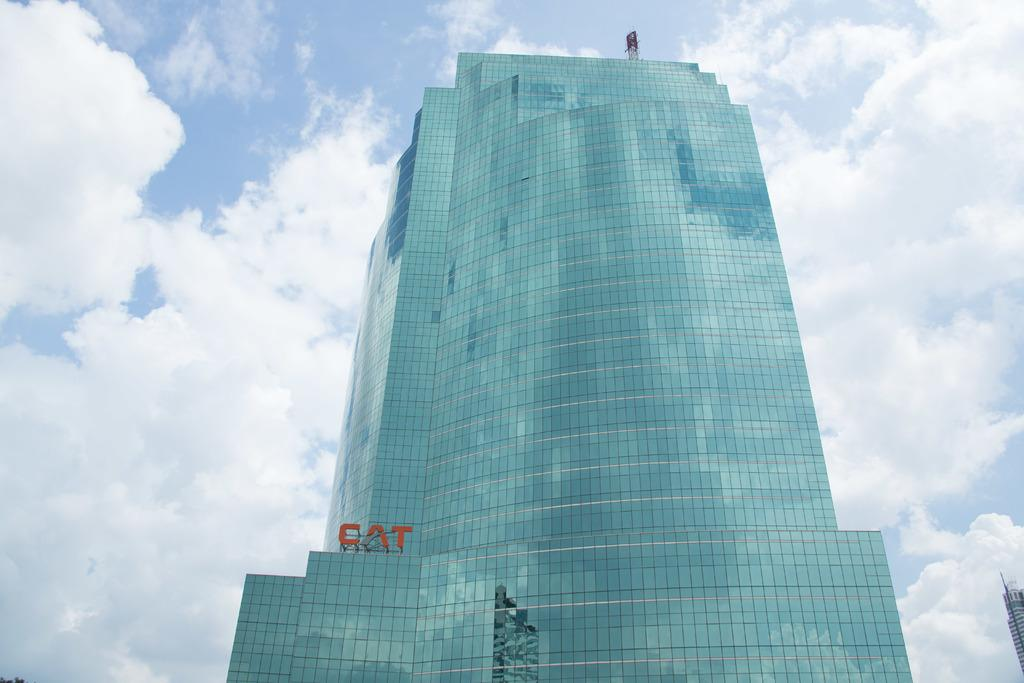<image>
Relay a brief, clear account of the picture shown. A large glass skyscraper with the CAT company name above the lower levels. 